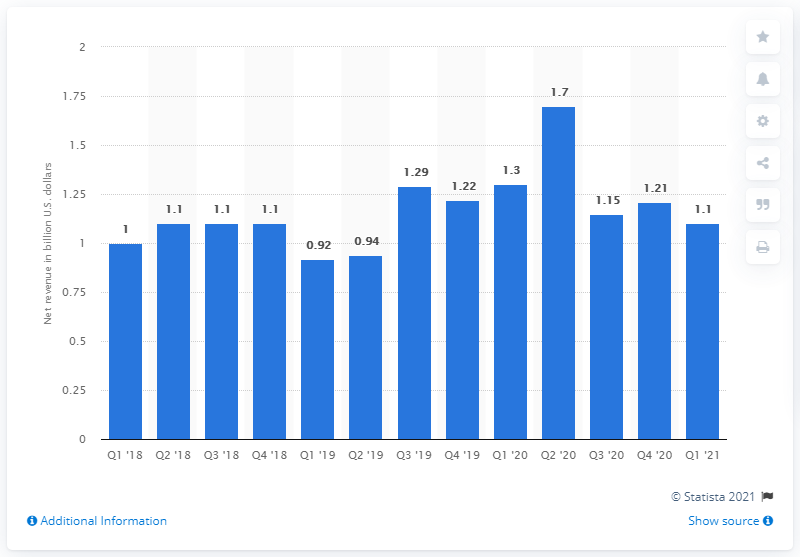Draw attention to some important aspects in this diagram. In the first quarter of 2021, NSG's revenue was 1.1. 